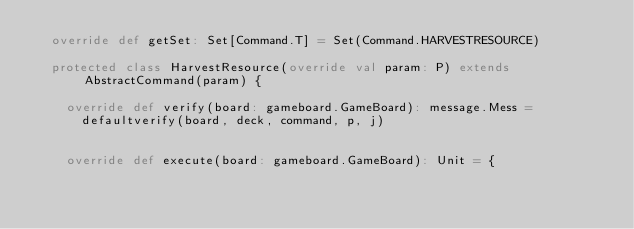<code> <loc_0><loc_0><loc_500><loc_500><_Scala_>  override def getSet: Set[Command.T] = Set(Command.HARVESTRESOURCE)

  protected class HarvestResource(override val param: P) extends AbstractCommand(param) {

    override def verify(board: gameboard.GameBoard): message.Mess =
      defaultverify(board, deck, command, p, j)


    override def execute(board: gameboard.GameBoard): Unit = {</code> 